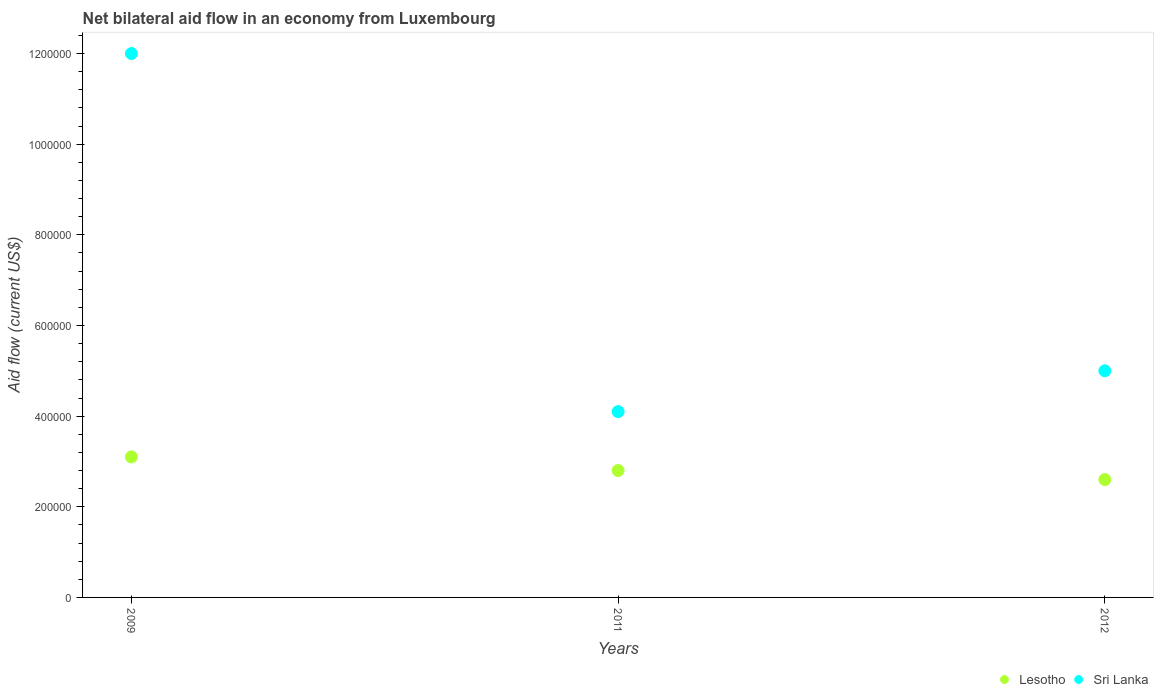Is the number of dotlines equal to the number of legend labels?
Your answer should be very brief. Yes. Across all years, what is the maximum net bilateral aid flow in Sri Lanka?
Give a very brief answer. 1.20e+06. In which year was the net bilateral aid flow in Sri Lanka minimum?
Keep it short and to the point. 2011. What is the total net bilateral aid flow in Sri Lanka in the graph?
Offer a very short reply. 2.11e+06. What is the difference between the net bilateral aid flow in Lesotho in 2011 and that in 2012?
Provide a short and direct response. 2.00e+04. What is the difference between the net bilateral aid flow in Lesotho in 2012 and the net bilateral aid flow in Sri Lanka in 2009?
Give a very brief answer. -9.40e+05. What is the average net bilateral aid flow in Sri Lanka per year?
Give a very brief answer. 7.03e+05. In the year 2009, what is the difference between the net bilateral aid flow in Lesotho and net bilateral aid flow in Sri Lanka?
Keep it short and to the point. -8.90e+05. In how many years, is the net bilateral aid flow in Lesotho greater than 600000 US$?
Your answer should be very brief. 0. What is the ratio of the net bilateral aid flow in Lesotho in 2009 to that in 2011?
Keep it short and to the point. 1.11. Is the difference between the net bilateral aid flow in Lesotho in 2011 and 2012 greater than the difference between the net bilateral aid flow in Sri Lanka in 2011 and 2012?
Make the answer very short. Yes. What is the difference between the highest and the lowest net bilateral aid flow in Sri Lanka?
Offer a very short reply. 7.90e+05. In how many years, is the net bilateral aid flow in Sri Lanka greater than the average net bilateral aid flow in Sri Lanka taken over all years?
Ensure brevity in your answer.  1. Does the net bilateral aid flow in Sri Lanka monotonically increase over the years?
Provide a short and direct response. No. Is the net bilateral aid flow in Lesotho strictly greater than the net bilateral aid flow in Sri Lanka over the years?
Your answer should be very brief. No. Is the net bilateral aid flow in Lesotho strictly less than the net bilateral aid flow in Sri Lanka over the years?
Your answer should be very brief. Yes. What is the difference between two consecutive major ticks on the Y-axis?
Your answer should be very brief. 2.00e+05. Does the graph contain grids?
Offer a very short reply. No. Where does the legend appear in the graph?
Your answer should be very brief. Bottom right. What is the title of the graph?
Keep it short and to the point. Net bilateral aid flow in an economy from Luxembourg. Does "Malta" appear as one of the legend labels in the graph?
Offer a terse response. No. What is the label or title of the Y-axis?
Keep it short and to the point. Aid flow (current US$). What is the Aid flow (current US$) in Sri Lanka in 2009?
Keep it short and to the point. 1.20e+06. What is the Aid flow (current US$) in Sri Lanka in 2011?
Offer a very short reply. 4.10e+05. What is the Aid flow (current US$) of Lesotho in 2012?
Offer a terse response. 2.60e+05. What is the Aid flow (current US$) in Sri Lanka in 2012?
Ensure brevity in your answer.  5.00e+05. Across all years, what is the maximum Aid flow (current US$) in Lesotho?
Your answer should be compact. 3.10e+05. Across all years, what is the maximum Aid flow (current US$) of Sri Lanka?
Offer a very short reply. 1.20e+06. Across all years, what is the minimum Aid flow (current US$) in Lesotho?
Offer a very short reply. 2.60e+05. What is the total Aid flow (current US$) in Lesotho in the graph?
Provide a short and direct response. 8.50e+05. What is the total Aid flow (current US$) of Sri Lanka in the graph?
Your response must be concise. 2.11e+06. What is the difference between the Aid flow (current US$) in Lesotho in 2009 and that in 2011?
Give a very brief answer. 3.00e+04. What is the difference between the Aid flow (current US$) of Sri Lanka in 2009 and that in 2011?
Offer a very short reply. 7.90e+05. What is the difference between the Aid flow (current US$) in Lesotho in 2009 and that in 2012?
Your response must be concise. 5.00e+04. What is the difference between the Aid flow (current US$) of Lesotho in 2011 and that in 2012?
Provide a succinct answer. 2.00e+04. What is the difference between the Aid flow (current US$) in Lesotho in 2009 and the Aid flow (current US$) in Sri Lanka in 2012?
Ensure brevity in your answer.  -1.90e+05. What is the difference between the Aid flow (current US$) of Lesotho in 2011 and the Aid flow (current US$) of Sri Lanka in 2012?
Your answer should be compact. -2.20e+05. What is the average Aid flow (current US$) of Lesotho per year?
Ensure brevity in your answer.  2.83e+05. What is the average Aid flow (current US$) in Sri Lanka per year?
Make the answer very short. 7.03e+05. In the year 2009, what is the difference between the Aid flow (current US$) in Lesotho and Aid flow (current US$) in Sri Lanka?
Ensure brevity in your answer.  -8.90e+05. In the year 2012, what is the difference between the Aid flow (current US$) in Lesotho and Aid flow (current US$) in Sri Lanka?
Provide a succinct answer. -2.40e+05. What is the ratio of the Aid flow (current US$) of Lesotho in 2009 to that in 2011?
Keep it short and to the point. 1.11. What is the ratio of the Aid flow (current US$) of Sri Lanka in 2009 to that in 2011?
Make the answer very short. 2.93. What is the ratio of the Aid flow (current US$) in Lesotho in 2009 to that in 2012?
Offer a very short reply. 1.19. What is the ratio of the Aid flow (current US$) in Sri Lanka in 2009 to that in 2012?
Your answer should be very brief. 2.4. What is the ratio of the Aid flow (current US$) of Lesotho in 2011 to that in 2012?
Provide a short and direct response. 1.08. What is the ratio of the Aid flow (current US$) in Sri Lanka in 2011 to that in 2012?
Your answer should be compact. 0.82. What is the difference between the highest and the second highest Aid flow (current US$) of Lesotho?
Provide a succinct answer. 3.00e+04. What is the difference between the highest and the second highest Aid flow (current US$) in Sri Lanka?
Make the answer very short. 7.00e+05. What is the difference between the highest and the lowest Aid flow (current US$) of Sri Lanka?
Ensure brevity in your answer.  7.90e+05. 